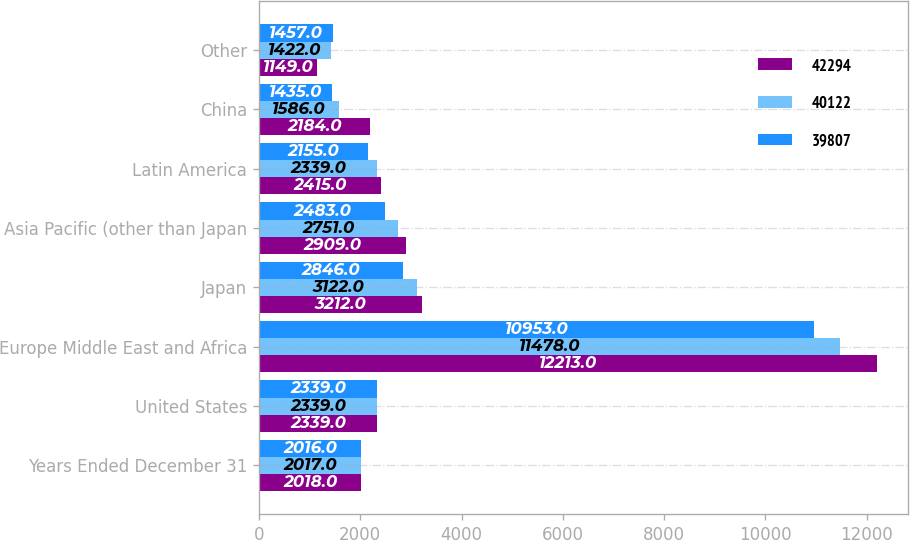Convert chart. <chart><loc_0><loc_0><loc_500><loc_500><stacked_bar_chart><ecel><fcel>Years Ended December 31<fcel>United States<fcel>Europe Middle East and Africa<fcel>Japan<fcel>Asia Pacific (other than Japan<fcel>Latin America<fcel>China<fcel>Other<nl><fcel>42294<fcel>2018<fcel>2339<fcel>12213<fcel>3212<fcel>2909<fcel>2415<fcel>2184<fcel>1149<nl><fcel>40122<fcel>2017<fcel>2339<fcel>11478<fcel>3122<fcel>2751<fcel>2339<fcel>1586<fcel>1422<nl><fcel>39807<fcel>2016<fcel>2339<fcel>10953<fcel>2846<fcel>2483<fcel>2155<fcel>1435<fcel>1457<nl></chart> 